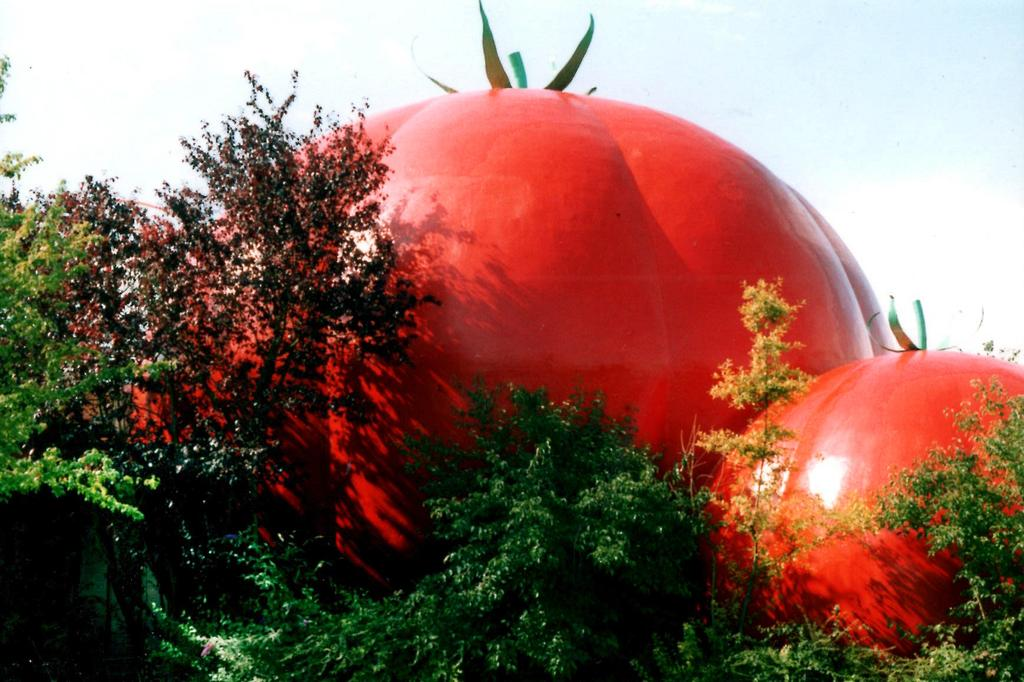What type of vegetation can be seen in the image? There are trees in the image. What unique structures are present in the image? There are structures in the shape of tomatoes in the image. What can be seen in the background of the image? The sky is visible in the background of the image. How many dogs are playing with the potato in the image? There are no dogs or potato present in the image. What type of property is visible in the image? There is no property visible in the image; it features trees and structures in the shape of tomatoes. 